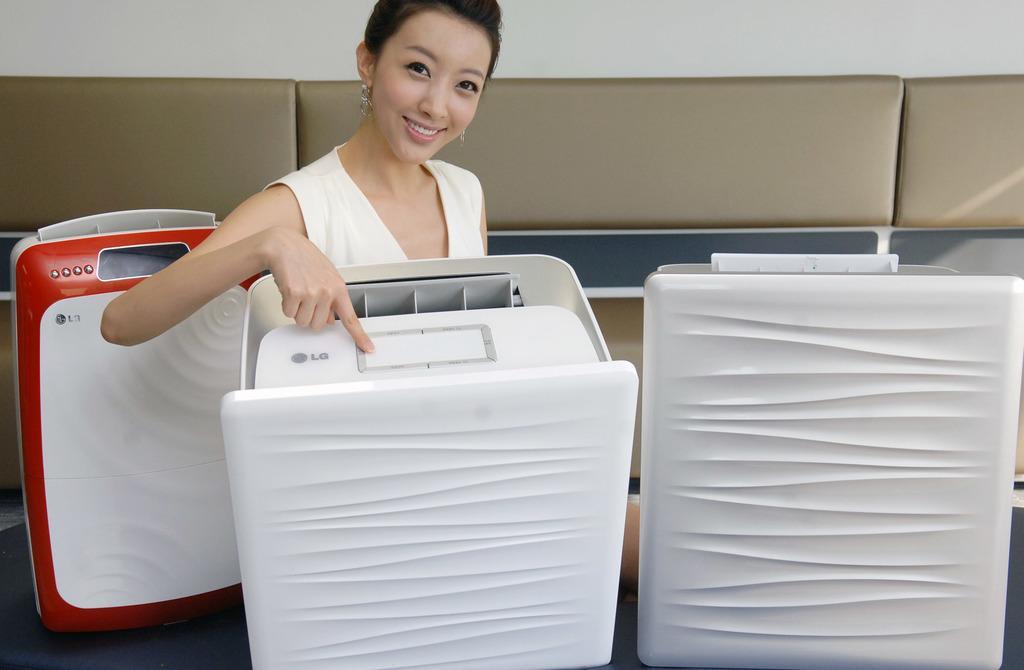Please provide a concise description of this image. This picture is taken inside the room. In this image, in the middle, we can see a woman standing in front of a electronic machine. On the right side, we can also see a box. On the left side, we can also see another box. In the background, we can see brown color and a wall. 